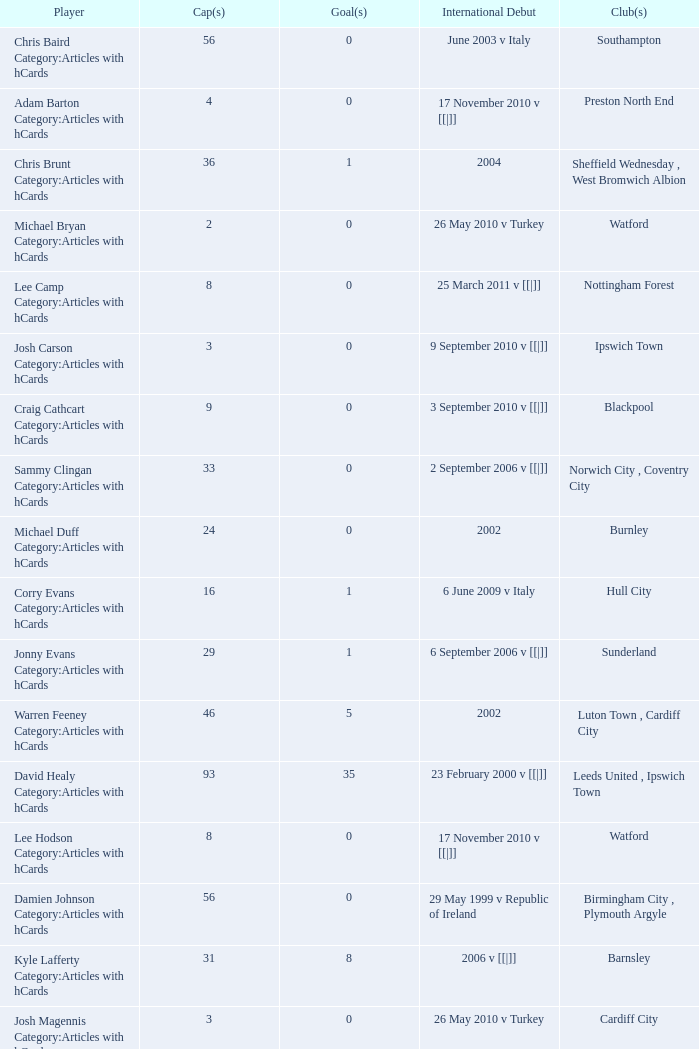How many cap counts are there for norwich city, coventry city? 1.0. 